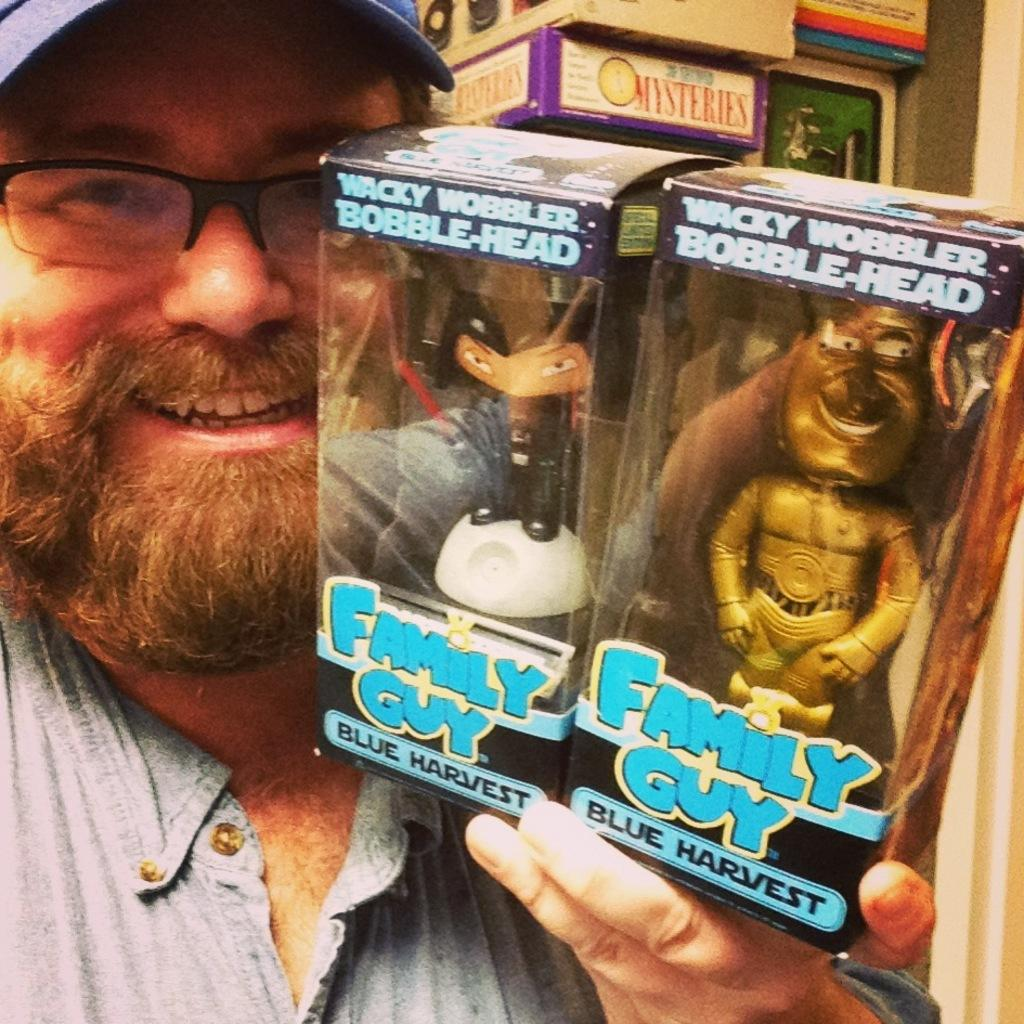What is the main subject of the image? There is a person in the image. What is the person holding in the image? The person is holding two boxes. What are the boxes containing? The boxes contain toys. Can you describe any other objects visible in the image? There are other objects visible behind the person. What color is the vein visible on the person's hands in the image? There is no vein visible on the person's hands in the image. Is the woman in the image wearing a hat? The provided facts do not mention a woman or a hat, so we cannot answer this question based on the information given. 